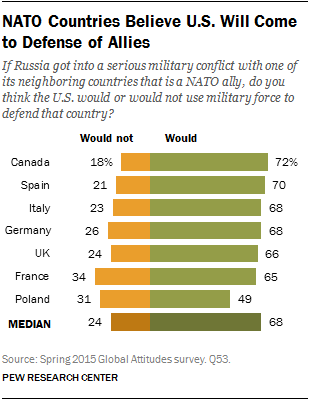Draw attention to some important aspects in this diagram. In fewer than 60% of countries, the majority of the population does not believe that the United States will come to the defense of its allies. A recent survey in Spain has revealed that a mere 0.7% of people believe that the US will come to the defense of its allies. This is a concerning statistic, as it suggests that many Spaniards do not trust the US to uphold its commitments to its allies. It is essential that the US rebuilds its alliances and demonstrates its commitment to international cooperation and security to maintain the trust and confidence of its allies. 